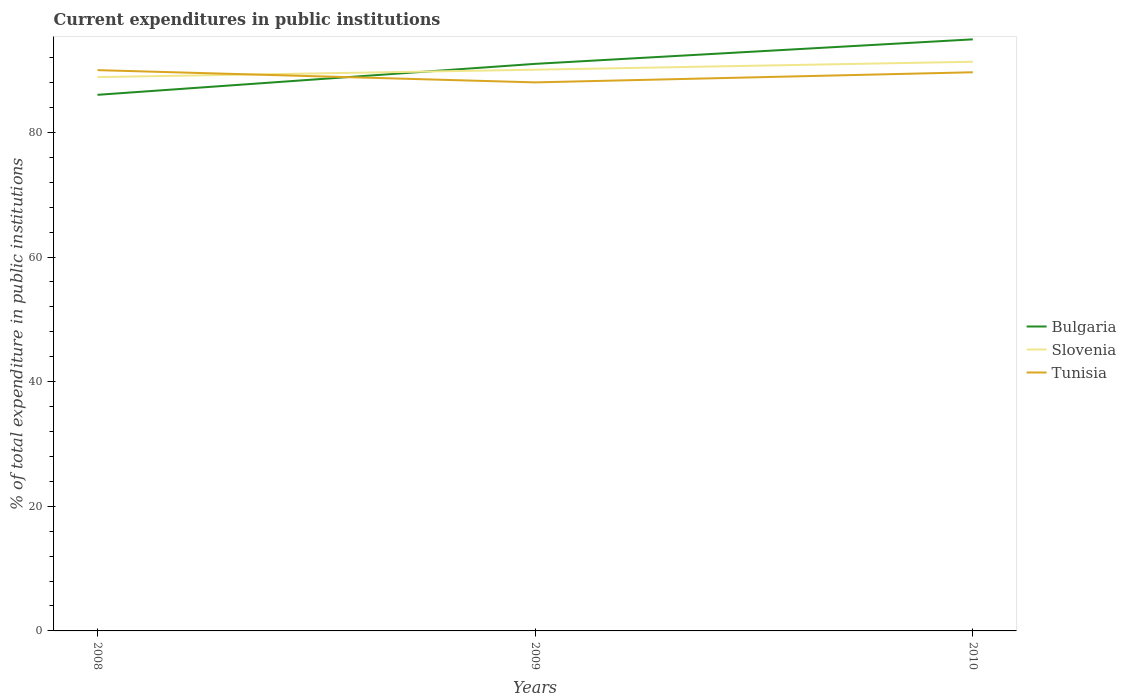Is the number of lines equal to the number of legend labels?
Your answer should be very brief. Yes. Across all years, what is the maximum current expenditures in public institutions in Slovenia?
Give a very brief answer. 88.87. In which year was the current expenditures in public institutions in Slovenia maximum?
Provide a short and direct response. 2008. What is the total current expenditures in public institutions in Slovenia in the graph?
Ensure brevity in your answer.  -1.28. What is the difference between the highest and the second highest current expenditures in public institutions in Tunisia?
Your answer should be compact. 1.97. Is the current expenditures in public institutions in Tunisia strictly greater than the current expenditures in public institutions in Slovenia over the years?
Provide a succinct answer. No. What is the difference between two consecutive major ticks on the Y-axis?
Your response must be concise. 20. Does the graph contain any zero values?
Give a very brief answer. No. Does the graph contain grids?
Provide a succinct answer. No. How are the legend labels stacked?
Provide a succinct answer. Vertical. What is the title of the graph?
Provide a succinct answer. Current expenditures in public institutions. Does "Gambia, The" appear as one of the legend labels in the graph?
Keep it short and to the point. No. What is the label or title of the X-axis?
Provide a short and direct response. Years. What is the label or title of the Y-axis?
Provide a short and direct response. % of total expenditure in public institutions. What is the % of total expenditure in public institutions in Bulgaria in 2008?
Ensure brevity in your answer.  86.03. What is the % of total expenditure in public institutions of Slovenia in 2008?
Your answer should be compact. 88.87. What is the % of total expenditure in public institutions in Tunisia in 2008?
Your answer should be very brief. 89.99. What is the % of total expenditure in public institutions of Bulgaria in 2009?
Ensure brevity in your answer.  91. What is the % of total expenditure in public institutions of Slovenia in 2009?
Ensure brevity in your answer.  90.06. What is the % of total expenditure in public institutions in Tunisia in 2009?
Keep it short and to the point. 88.02. What is the % of total expenditure in public institutions of Bulgaria in 2010?
Keep it short and to the point. 94.93. What is the % of total expenditure in public institutions of Slovenia in 2010?
Give a very brief answer. 91.34. What is the % of total expenditure in public institutions in Tunisia in 2010?
Give a very brief answer. 89.65. Across all years, what is the maximum % of total expenditure in public institutions in Bulgaria?
Ensure brevity in your answer.  94.93. Across all years, what is the maximum % of total expenditure in public institutions of Slovenia?
Your response must be concise. 91.34. Across all years, what is the maximum % of total expenditure in public institutions of Tunisia?
Provide a succinct answer. 89.99. Across all years, what is the minimum % of total expenditure in public institutions in Bulgaria?
Your response must be concise. 86.03. Across all years, what is the minimum % of total expenditure in public institutions in Slovenia?
Ensure brevity in your answer.  88.87. Across all years, what is the minimum % of total expenditure in public institutions of Tunisia?
Your answer should be compact. 88.02. What is the total % of total expenditure in public institutions of Bulgaria in the graph?
Ensure brevity in your answer.  271.96. What is the total % of total expenditure in public institutions of Slovenia in the graph?
Keep it short and to the point. 270.27. What is the total % of total expenditure in public institutions in Tunisia in the graph?
Provide a short and direct response. 267.66. What is the difference between the % of total expenditure in public institutions in Bulgaria in 2008 and that in 2009?
Give a very brief answer. -4.97. What is the difference between the % of total expenditure in public institutions of Slovenia in 2008 and that in 2009?
Offer a terse response. -1.19. What is the difference between the % of total expenditure in public institutions in Tunisia in 2008 and that in 2009?
Your answer should be compact. 1.97. What is the difference between the % of total expenditure in public institutions in Bulgaria in 2008 and that in 2010?
Your answer should be very brief. -8.9. What is the difference between the % of total expenditure in public institutions of Slovenia in 2008 and that in 2010?
Make the answer very short. -2.46. What is the difference between the % of total expenditure in public institutions of Tunisia in 2008 and that in 2010?
Ensure brevity in your answer.  0.34. What is the difference between the % of total expenditure in public institutions of Bulgaria in 2009 and that in 2010?
Offer a very short reply. -3.93. What is the difference between the % of total expenditure in public institutions of Slovenia in 2009 and that in 2010?
Your answer should be very brief. -1.28. What is the difference between the % of total expenditure in public institutions in Tunisia in 2009 and that in 2010?
Offer a terse response. -1.62. What is the difference between the % of total expenditure in public institutions in Bulgaria in 2008 and the % of total expenditure in public institutions in Slovenia in 2009?
Ensure brevity in your answer.  -4.03. What is the difference between the % of total expenditure in public institutions of Bulgaria in 2008 and the % of total expenditure in public institutions of Tunisia in 2009?
Give a very brief answer. -2. What is the difference between the % of total expenditure in public institutions of Slovenia in 2008 and the % of total expenditure in public institutions of Tunisia in 2009?
Ensure brevity in your answer.  0.85. What is the difference between the % of total expenditure in public institutions in Bulgaria in 2008 and the % of total expenditure in public institutions in Slovenia in 2010?
Provide a short and direct response. -5.31. What is the difference between the % of total expenditure in public institutions in Bulgaria in 2008 and the % of total expenditure in public institutions in Tunisia in 2010?
Your answer should be compact. -3.62. What is the difference between the % of total expenditure in public institutions in Slovenia in 2008 and the % of total expenditure in public institutions in Tunisia in 2010?
Ensure brevity in your answer.  -0.78. What is the difference between the % of total expenditure in public institutions of Bulgaria in 2009 and the % of total expenditure in public institutions of Slovenia in 2010?
Offer a terse response. -0.34. What is the difference between the % of total expenditure in public institutions of Bulgaria in 2009 and the % of total expenditure in public institutions of Tunisia in 2010?
Provide a succinct answer. 1.35. What is the difference between the % of total expenditure in public institutions in Slovenia in 2009 and the % of total expenditure in public institutions in Tunisia in 2010?
Provide a short and direct response. 0.41. What is the average % of total expenditure in public institutions in Bulgaria per year?
Provide a succinct answer. 90.65. What is the average % of total expenditure in public institutions of Slovenia per year?
Your answer should be very brief. 90.09. What is the average % of total expenditure in public institutions of Tunisia per year?
Keep it short and to the point. 89.22. In the year 2008, what is the difference between the % of total expenditure in public institutions of Bulgaria and % of total expenditure in public institutions of Slovenia?
Your response must be concise. -2.84. In the year 2008, what is the difference between the % of total expenditure in public institutions in Bulgaria and % of total expenditure in public institutions in Tunisia?
Offer a very short reply. -3.96. In the year 2008, what is the difference between the % of total expenditure in public institutions of Slovenia and % of total expenditure in public institutions of Tunisia?
Keep it short and to the point. -1.12. In the year 2009, what is the difference between the % of total expenditure in public institutions of Bulgaria and % of total expenditure in public institutions of Slovenia?
Your answer should be compact. 0.94. In the year 2009, what is the difference between the % of total expenditure in public institutions in Bulgaria and % of total expenditure in public institutions in Tunisia?
Your answer should be compact. 2.97. In the year 2009, what is the difference between the % of total expenditure in public institutions of Slovenia and % of total expenditure in public institutions of Tunisia?
Your answer should be compact. 2.03. In the year 2010, what is the difference between the % of total expenditure in public institutions in Bulgaria and % of total expenditure in public institutions in Slovenia?
Offer a terse response. 3.6. In the year 2010, what is the difference between the % of total expenditure in public institutions in Bulgaria and % of total expenditure in public institutions in Tunisia?
Provide a succinct answer. 5.28. In the year 2010, what is the difference between the % of total expenditure in public institutions of Slovenia and % of total expenditure in public institutions of Tunisia?
Offer a very short reply. 1.69. What is the ratio of the % of total expenditure in public institutions in Bulgaria in 2008 to that in 2009?
Offer a terse response. 0.95. What is the ratio of the % of total expenditure in public institutions of Slovenia in 2008 to that in 2009?
Provide a short and direct response. 0.99. What is the ratio of the % of total expenditure in public institutions of Tunisia in 2008 to that in 2009?
Provide a succinct answer. 1.02. What is the ratio of the % of total expenditure in public institutions in Bulgaria in 2008 to that in 2010?
Provide a short and direct response. 0.91. What is the ratio of the % of total expenditure in public institutions in Bulgaria in 2009 to that in 2010?
Your answer should be very brief. 0.96. What is the ratio of the % of total expenditure in public institutions of Tunisia in 2009 to that in 2010?
Your answer should be compact. 0.98. What is the difference between the highest and the second highest % of total expenditure in public institutions of Bulgaria?
Your answer should be very brief. 3.93. What is the difference between the highest and the second highest % of total expenditure in public institutions in Slovenia?
Make the answer very short. 1.28. What is the difference between the highest and the second highest % of total expenditure in public institutions in Tunisia?
Keep it short and to the point. 0.34. What is the difference between the highest and the lowest % of total expenditure in public institutions in Bulgaria?
Provide a short and direct response. 8.9. What is the difference between the highest and the lowest % of total expenditure in public institutions in Slovenia?
Your answer should be very brief. 2.46. What is the difference between the highest and the lowest % of total expenditure in public institutions of Tunisia?
Your response must be concise. 1.97. 